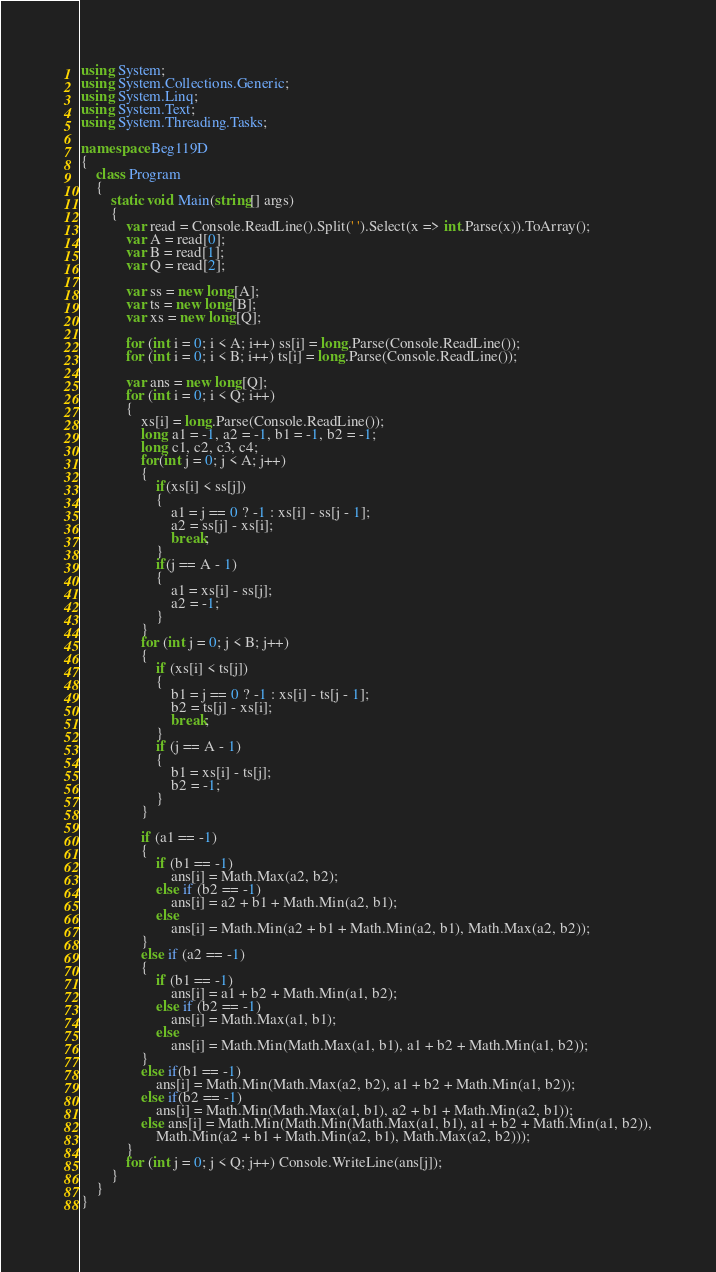Convert code to text. <code><loc_0><loc_0><loc_500><loc_500><_C#_>using System;
using System.Collections.Generic;
using System.Linq;
using System.Text;
using System.Threading.Tasks;

namespace Beg119D
{
    class Program
    {
        static void Main(string[] args)
        {
            var read = Console.ReadLine().Split(' ').Select(x => int.Parse(x)).ToArray();
            var A = read[0];
            var B = read[1];
            var Q = read[2];

            var ss = new long[A];
            var ts = new long[B];
            var xs = new long[Q];

            for (int i = 0; i < A; i++) ss[i] = long.Parse(Console.ReadLine());
            for (int i = 0; i < B; i++) ts[i] = long.Parse(Console.ReadLine());

            var ans = new long[Q];
            for (int i = 0; i < Q; i++)
            {
                xs[i] = long.Parse(Console.ReadLine());
                long a1 = -1, a2 = -1, b1 = -1, b2 = -1; 
                long c1, c2, c3, c4;
                for(int j = 0; j < A; j++)
                {
                    if(xs[i] < ss[j])
                    {
                        a1 = j == 0 ? -1 : xs[i] - ss[j - 1];
                        a2 = ss[j] - xs[i];
                        break;
                    }
                    if(j == A - 1)
                    {
                        a1 = xs[i] - ss[j];
                        a2 = -1;
                    }
                }
                for (int j = 0; j < B; j++)
                {
                    if (xs[i] < ts[j])
                    {
                        b1 = j == 0 ? -1 : xs[i] - ts[j - 1];
                        b2 = ts[j] - xs[i];
                        break;
                    }
                    if (j == A - 1)
                    {
                        b1 = xs[i] - ts[j];
                        b2 = -1;
                    }
                }

                if (a1 == -1)
                {
                    if (b1 == -1)
                        ans[i] = Math.Max(a2, b2);
                    else if (b2 == -1)
                        ans[i] = a2 + b1 + Math.Min(a2, b1);
                    else
                        ans[i] = Math.Min(a2 + b1 + Math.Min(a2, b1), Math.Max(a2, b2));
                }
                else if (a2 == -1)
                {
                    if (b1 == -1)
                        ans[i] = a1 + b2 + Math.Min(a1, b2);
                    else if (b2 == -1)
                        ans[i] = Math.Max(a1, b1);
                    else
                        ans[i] = Math.Min(Math.Max(a1, b1), a1 + b2 + Math.Min(a1, b2));
                }
                else if(b1 == -1)
                    ans[i] = Math.Min(Math.Max(a2, b2), a1 + b2 + Math.Min(a1, b2));
                else if(b2 == -1)
                    ans[i] = Math.Min(Math.Max(a1, b1), a2 + b1 + Math.Min(a2, b1));
                else ans[i] = Math.Min(Math.Min(Math.Max(a1, b1), a1 + b2 + Math.Min(a1, b2)),
                    Math.Min(a2 + b1 + Math.Min(a2, b1), Math.Max(a2, b2)));
            }
            for (int j = 0; j < Q; j++) Console.WriteLine(ans[j]);
        }
    }
}
</code> 